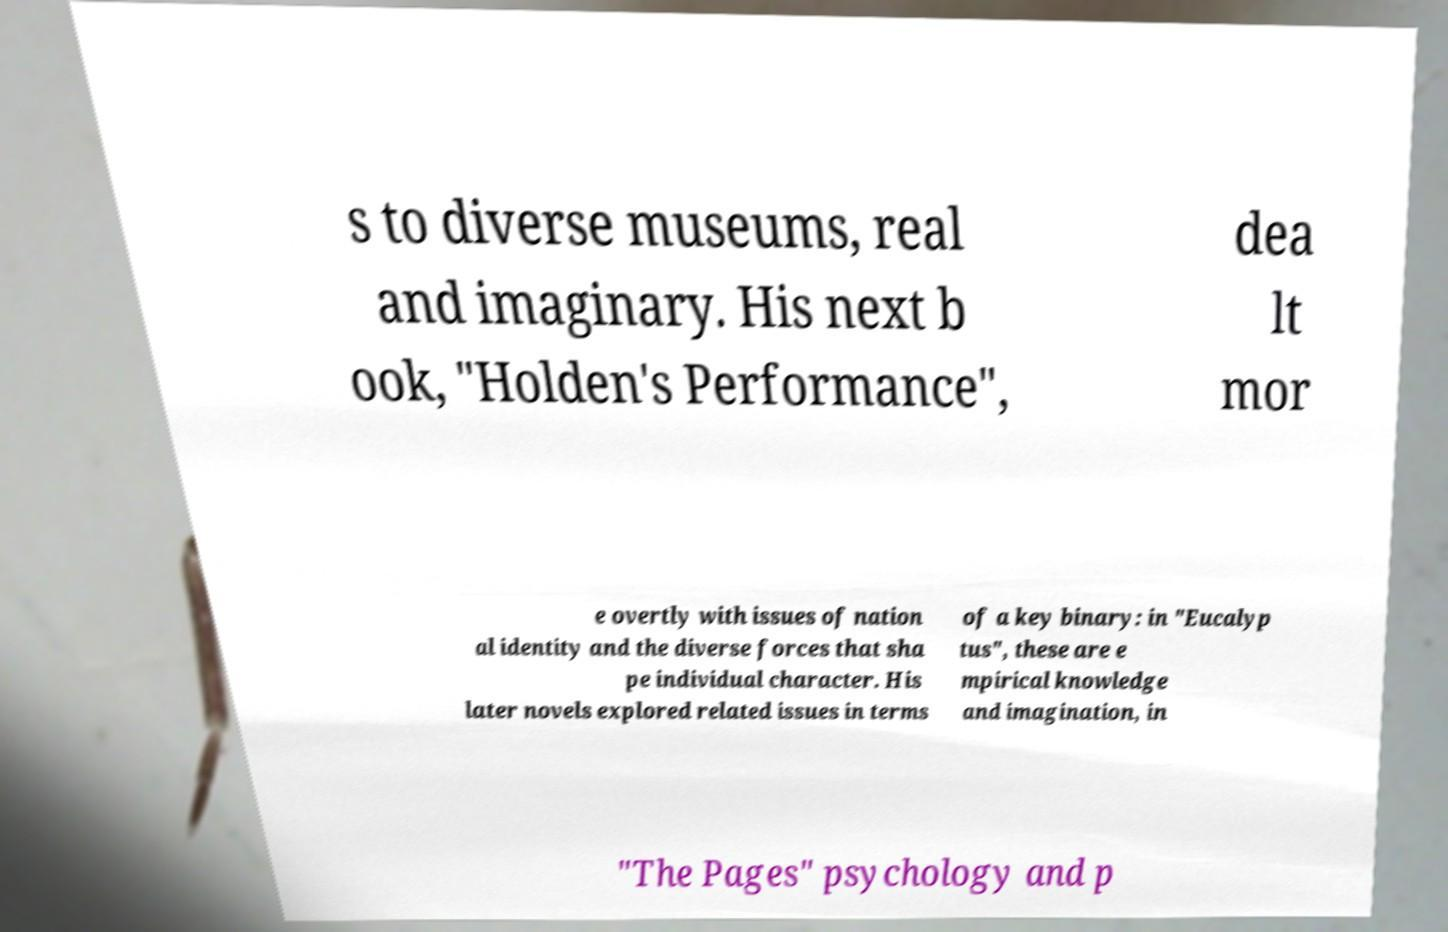Please read and relay the text visible in this image. What does it say? s to diverse museums, real and imaginary. His next b ook, "Holden's Performance", dea lt mor e overtly with issues of nation al identity and the diverse forces that sha pe individual character. His later novels explored related issues in terms of a key binary: in "Eucalyp tus", these are e mpirical knowledge and imagination, in "The Pages" psychology and p 